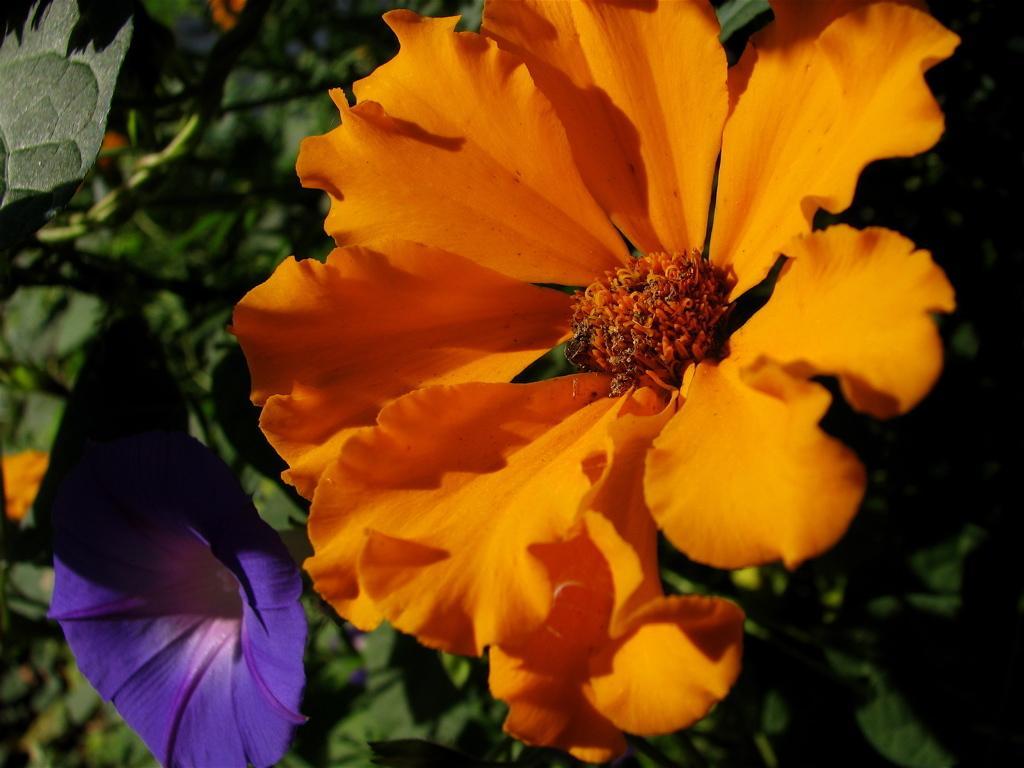In one or two sentences, can you explain what this image depicts? In this image I can see two flowers in the front and I can also see leaves in the background. I can see color of these flowers are purple and orange and I can see this image is little bit blurry in the background. 